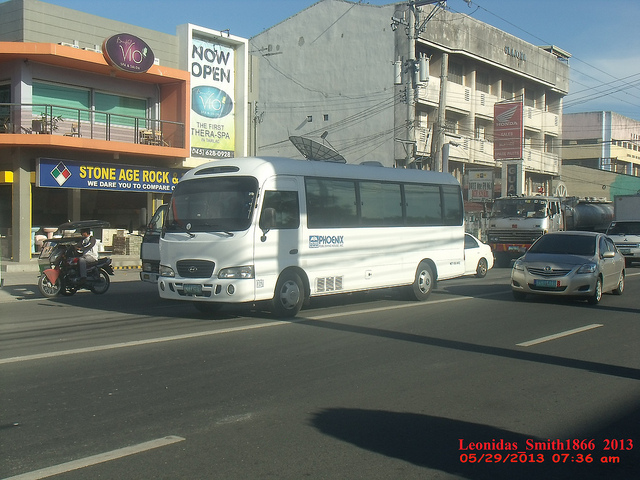<image>Where is the bus going? It is unanswerable where the bus is going. It could be going to Phoenix, downtown or a bus stop. Where is the bus going? I don't know where the bus is going. It can be going to Phoenix, downtown, the bus stop or just driving. 